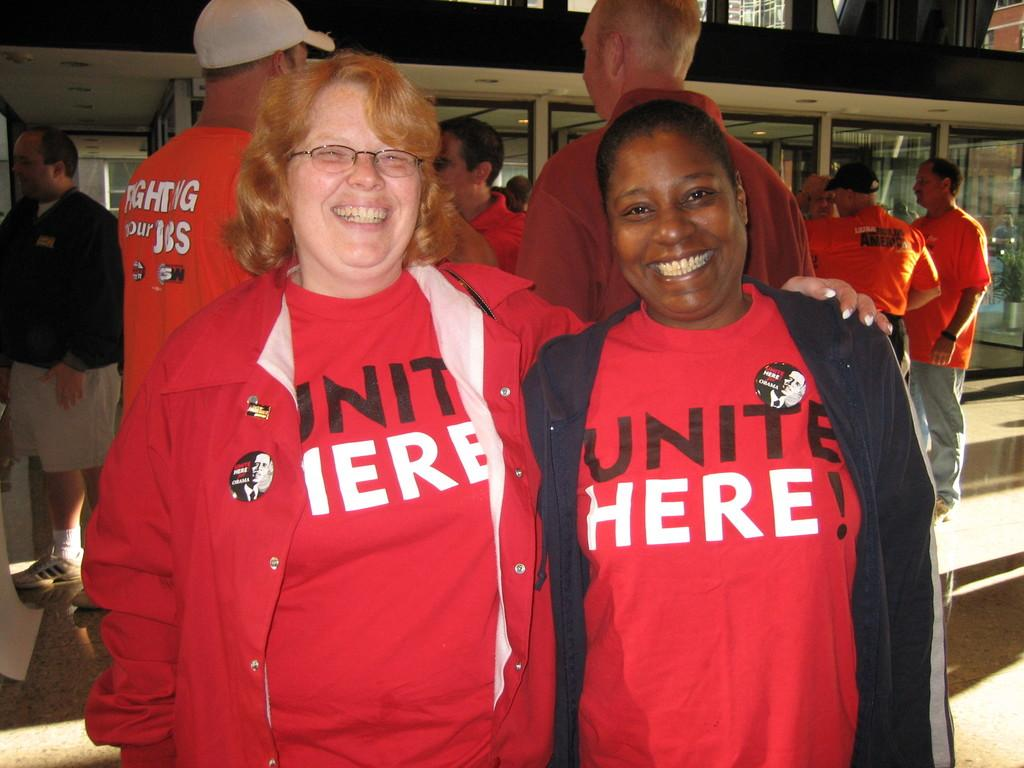<image>
Create a compact narrative representing the image presented. Two women wearing Unite here shirts stand side by side. 